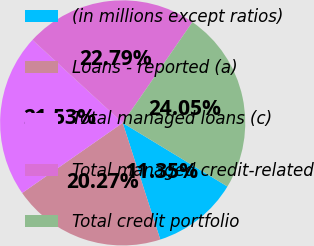Convert chart. <chart><loc_0><loc_0><loc_500><loc_500><pie_chart><fcel>(in millions except ratios)<fcel>Loans - reported (a)<fcel>Total managed loans (c)<fcel>Total managed credit-related<fcel>Total credit portfolio<nl><fcel>11.35%<fcel>20.27%<fcel>21.53%<fcel>22.79%<fcel>24.05%<nl></chart> 